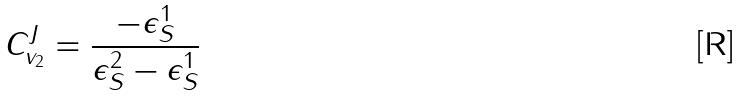Convert formula to latex. <formula><loc_0><loc_0><loc_500><loc_500>C _ { v _ { 2 } } ^ { J } = \frac { - \epsilon _ { S } ^ { 1 } } { \epsilon _ { S } ^ { 2 } - \epsilon _ { S } ^ { 1 } }</formula> 